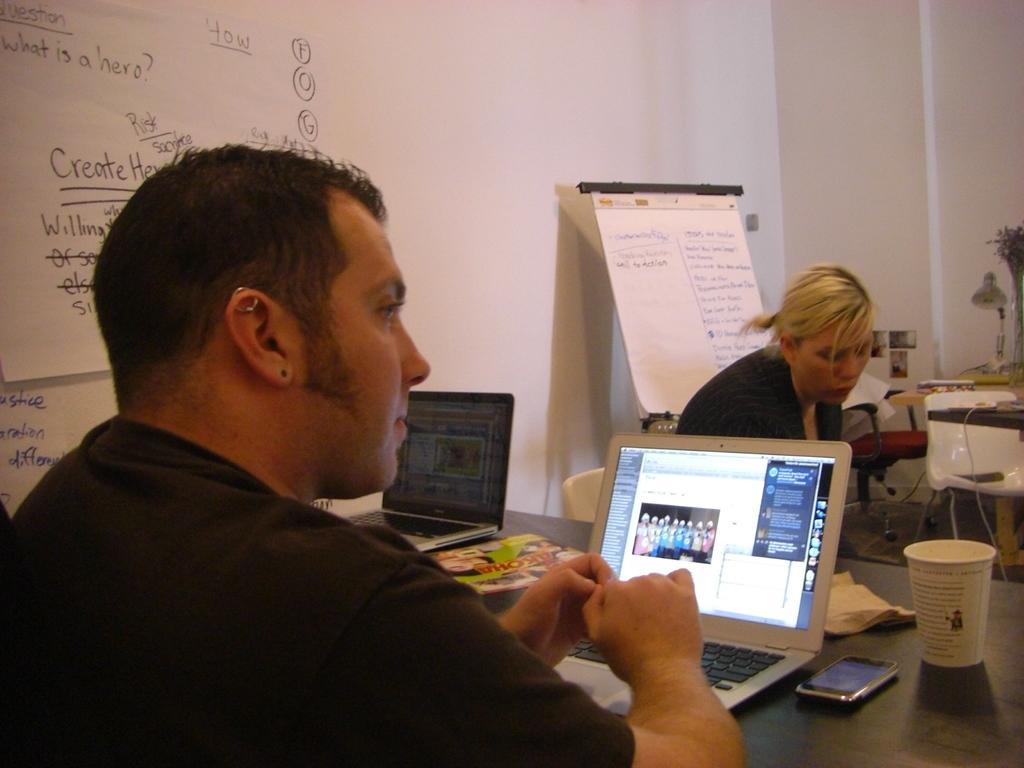How would you summarize this image in a sentence or two? In this image there is a person sitting at the center. There is a laptop on the table. In the background of the image there is a another lady. There is a wall. 